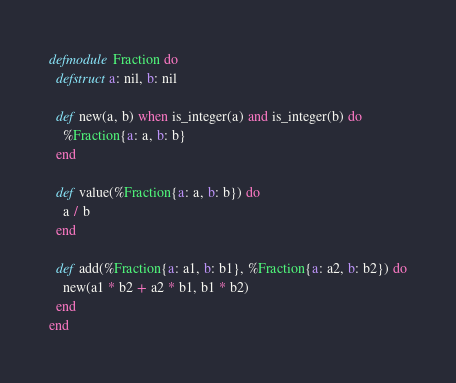Convert code to text. <code><loc_0><loc_0><loc_500><loc_500><_Elixir_>defmodule Fraction do
  defstruct a: nil, b: nil

  def new(a, b) when is_integer(a) and is_integer(b) do
    %Fraction{a: a, b: b}
  end

  def value(%Fraction{a: a, b: b}) do
    a / b
  end

  def add(%Fraction{a: a1, b: b1}, %Fraction{a: a2, b: b2}) do
    new(a1 * b2 + a2 * b1, b1 * b2)
  end
end
</code> 